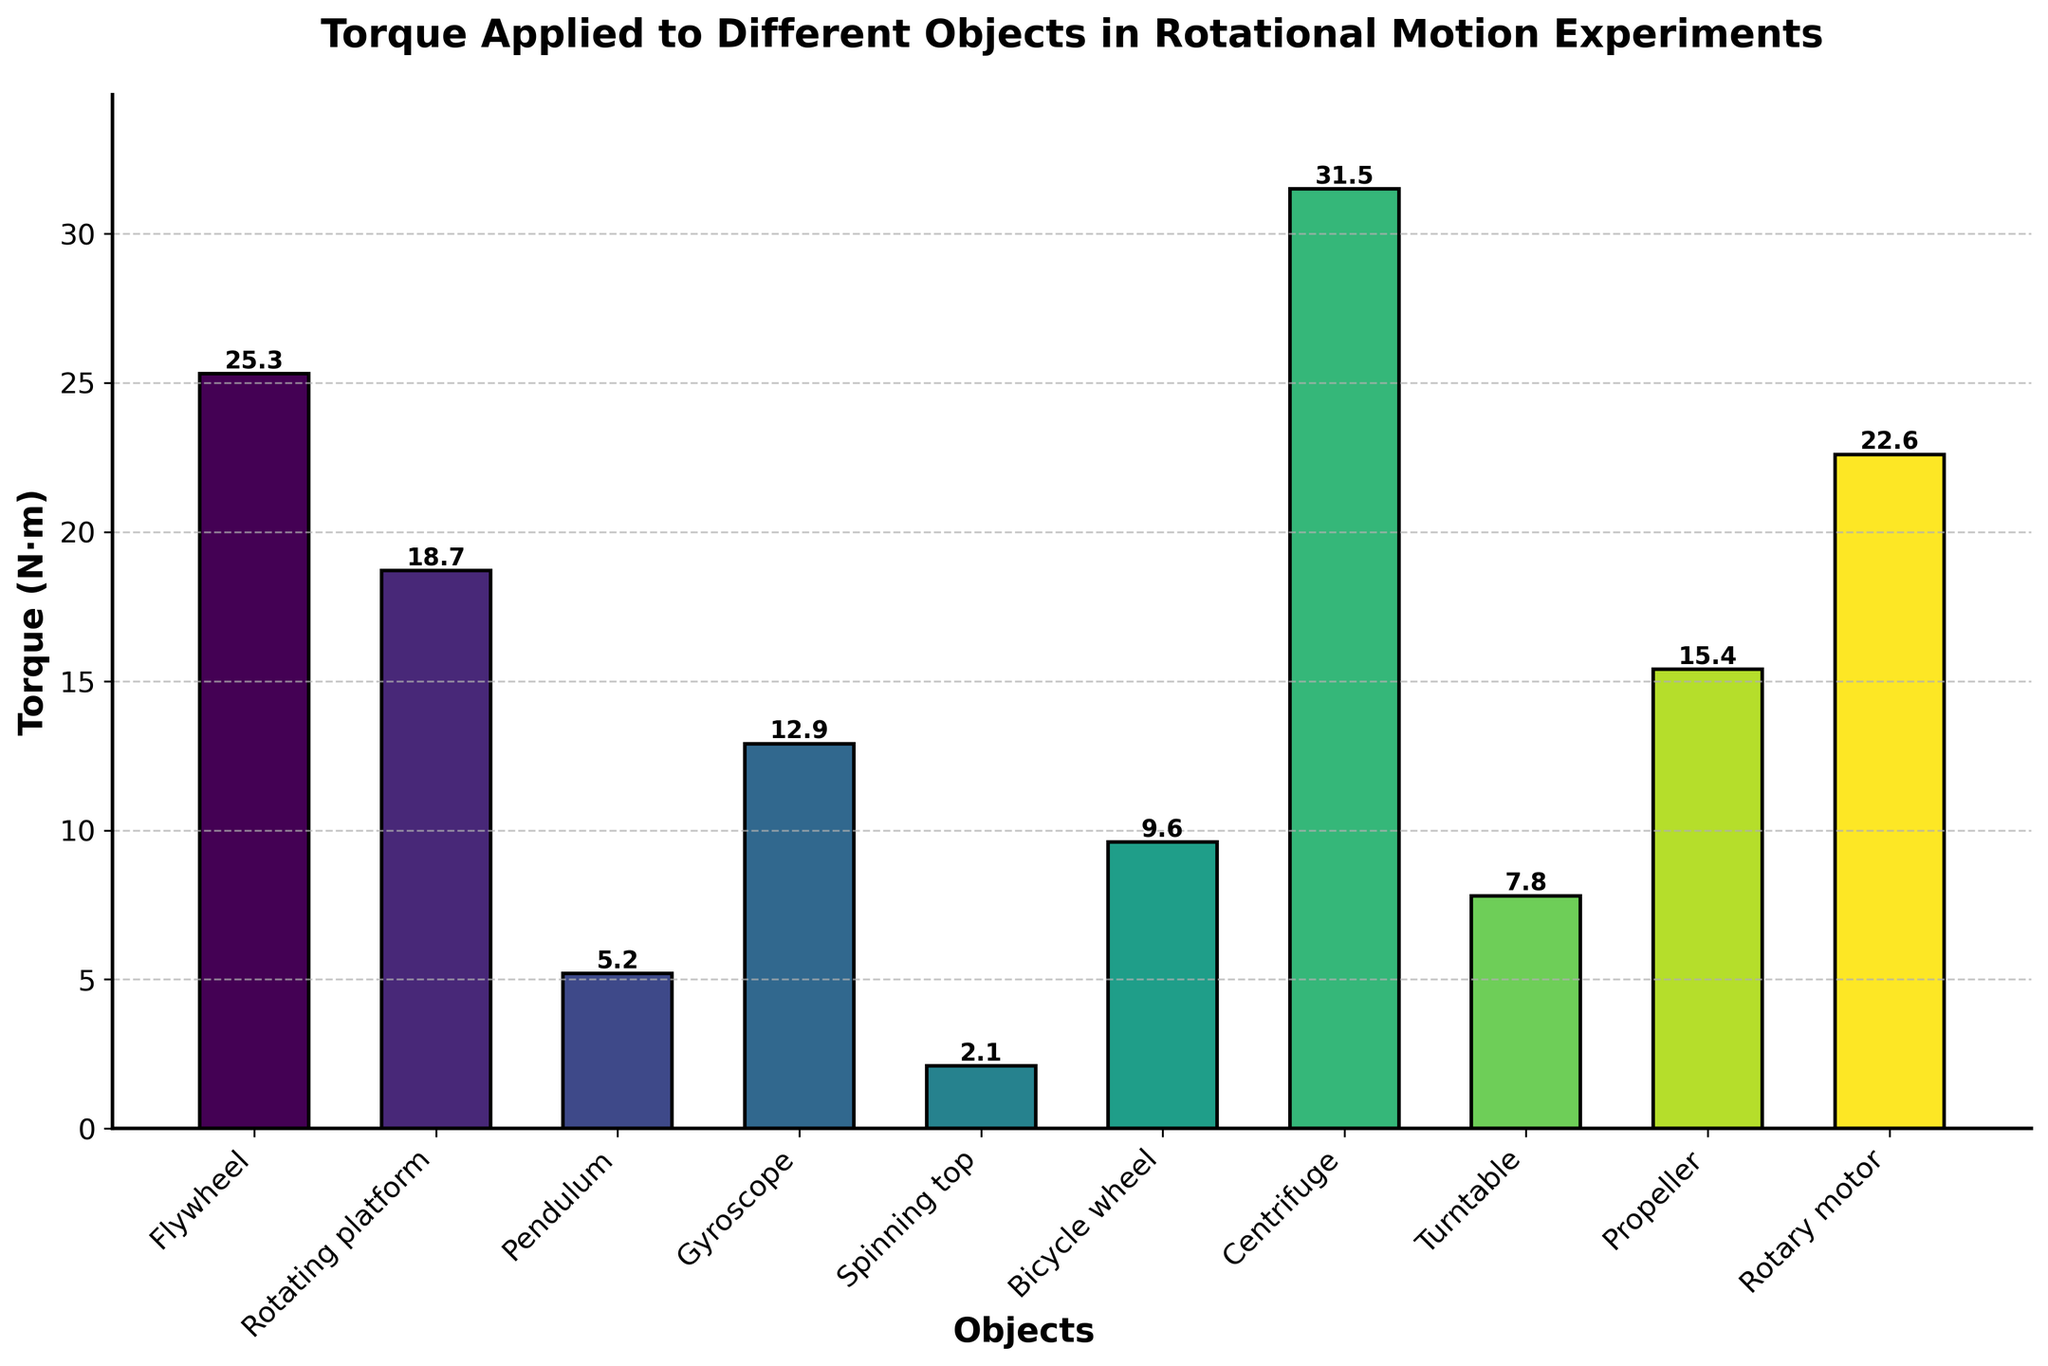Which object has the highest torque? The object with the highest bar represents the highest torque. By looking at the figure, the Centrifuge has the highest torque value.
Answer: Centrifuge What is the difference in torque between the Flywheel and the Rotary motor? The torque for the Flywheel is 25.3 N·m and for the Rotary motor is 22.6 N·m. The difference is calculated by subtracting the smaller value from the larger value: 25.3 - 22.6.
Answer: 2.7 N·m Which object has the lowest torque? The object with the shortest bar represents the lowest torque. By looking at the figure, the Spinning top has the lowest torque value.
Answer: Spinning top What is the total torque of the Gyroscope, Bicycle wheel, and Turntable combined? The torques are 12.9 N·m (Gyroscope), 9.6 N·m (Bicycle wheel), and 7.8 N·m (Turntable). Summing them up: 12.9 + 9.6 + 7.8.
Answer: 30.3 N·m Are there more objects with torque values greater than or less than 15 N·m? We count the objects with torques above and below 15 N·m. Torques greater than 15 N·m are Flywheel, Centrifuge, Propeller, Rotary motor. This is 4 objects. Torques less than 15 N·m are Rotating platform, Pendulum, Gyroscope, Spinning top, Bicycle wheel, Turntable. This is 6 objects.
Answer: Less than What is the average torque of all the objects? To find the average, sum all torques and divide by the number of objects: (25.3 + 18.7 + 5.2 + 12.9 + 2.1 + 9.6 + 31.5 + 7.8 + 15.4 + 22.6) / 10.
Answer: 15.11 N·m Which objects have torques greater than the average torque? Calculate the average torque first, which is 15.11 N·m. The objects with torques greater than 15.11 N·m are Flywheel, Centrifuge, Propeller, Rotary motor.
Answer: Flywheel, Centrifuge, Propeller, Rotary motor Which two objects have torques that differ by the smallest amount? Calculate the absolute differences between all pairs of torques. The smallest difference is between Gyroscope (12.9 N·m) and Bicycle wheel (9.6 N·m):
Answer: Gyroscope and Bicycle wheel 